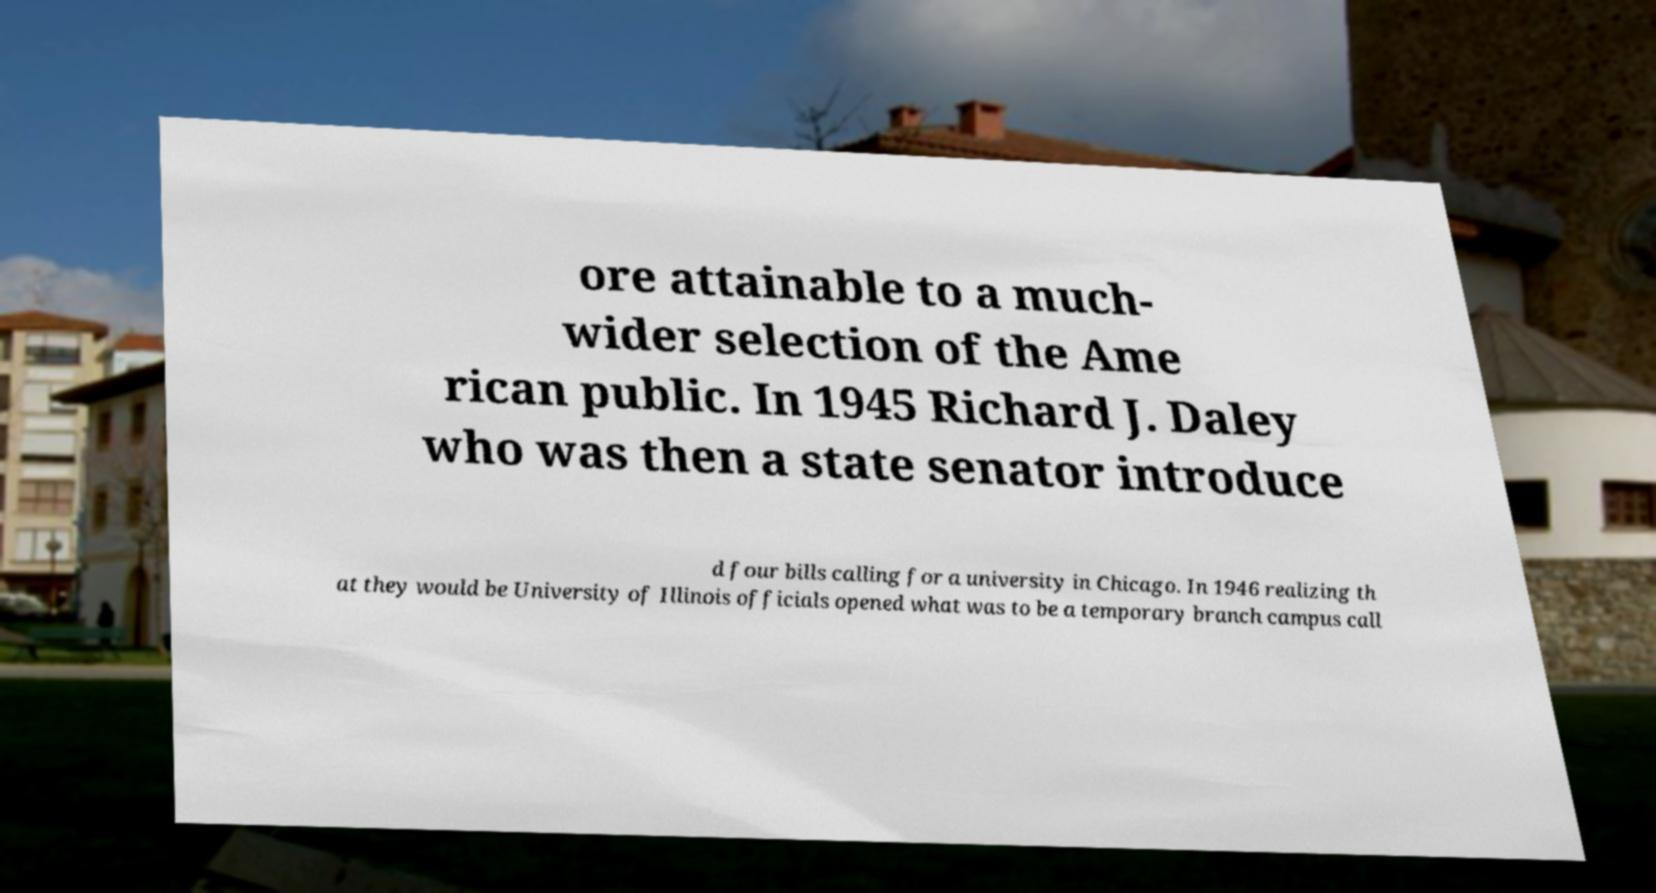I need the written content from this picture converted into text. Can you do that? ore attainable to a much- wider selection of the Ame rican public. In 1945 Richard J. Daley who was then a state senator introduce d four bills calling for a university in Chicago. In 1946 realizing th at they would be University of Illinois officials opened what was to be a temporary branch campus call 